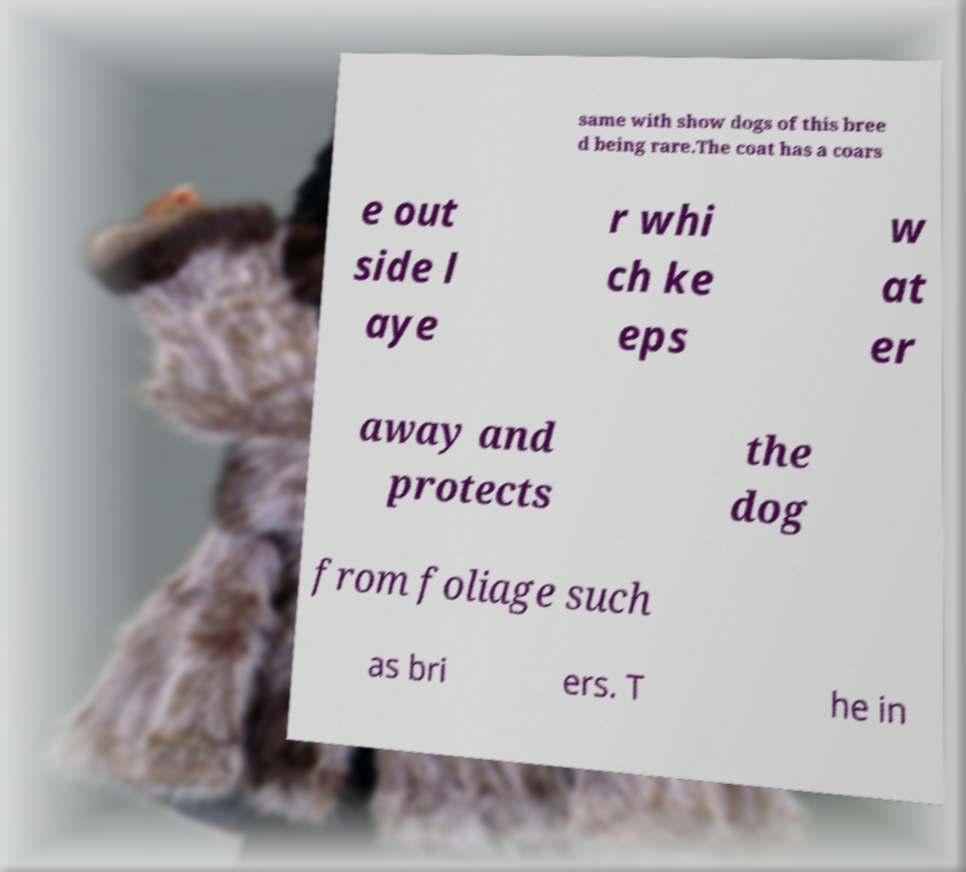What messages or text are displayed in this image? I need them in a readable, typed format. same with show dogs of this bree d being rare.The coat has a coars e out side l aye r whi ch ke eps w at er away and protects the dog from foliage such as bri ers. T he in 